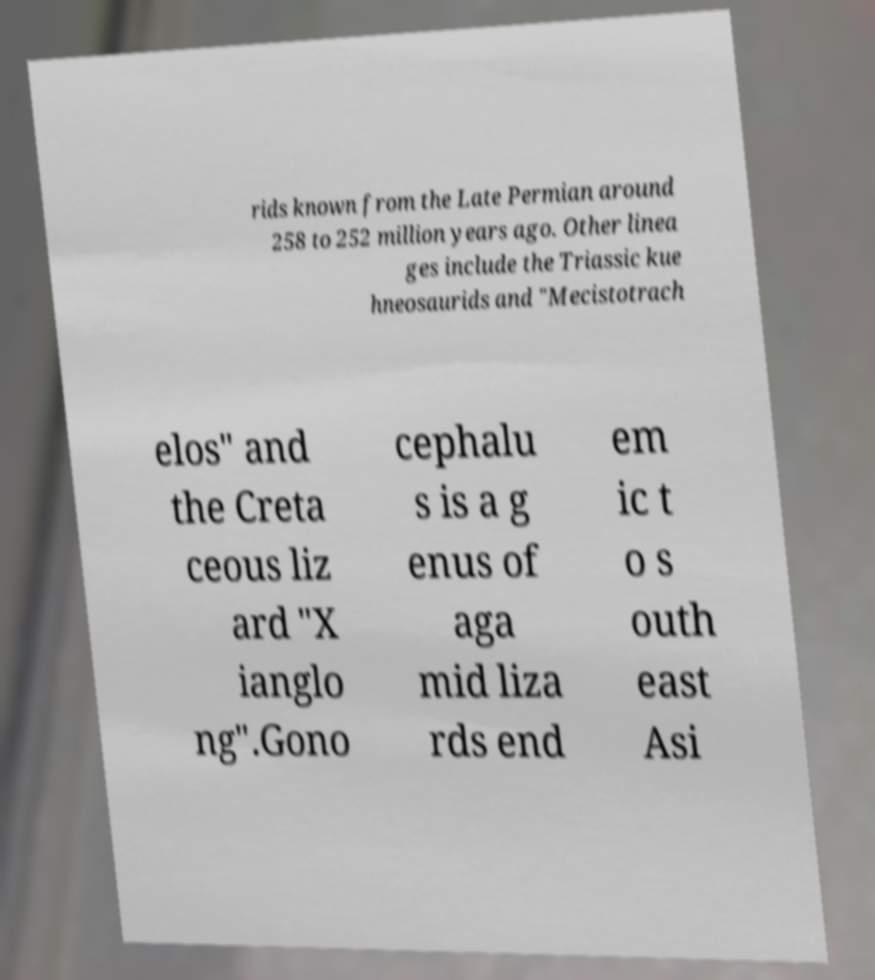Please identify and transcribe the text found in this image. rids known from the Late Permian around 258 to 252 million years ago. Other linea ges include the Triassic kue hneosaurids and "Mecistotrach elos" and the Creta ceous liz ard "X ianglo ng".Gono cephalu s is a g enus of aga mid liza rds end em ic t o s outh east Asi 